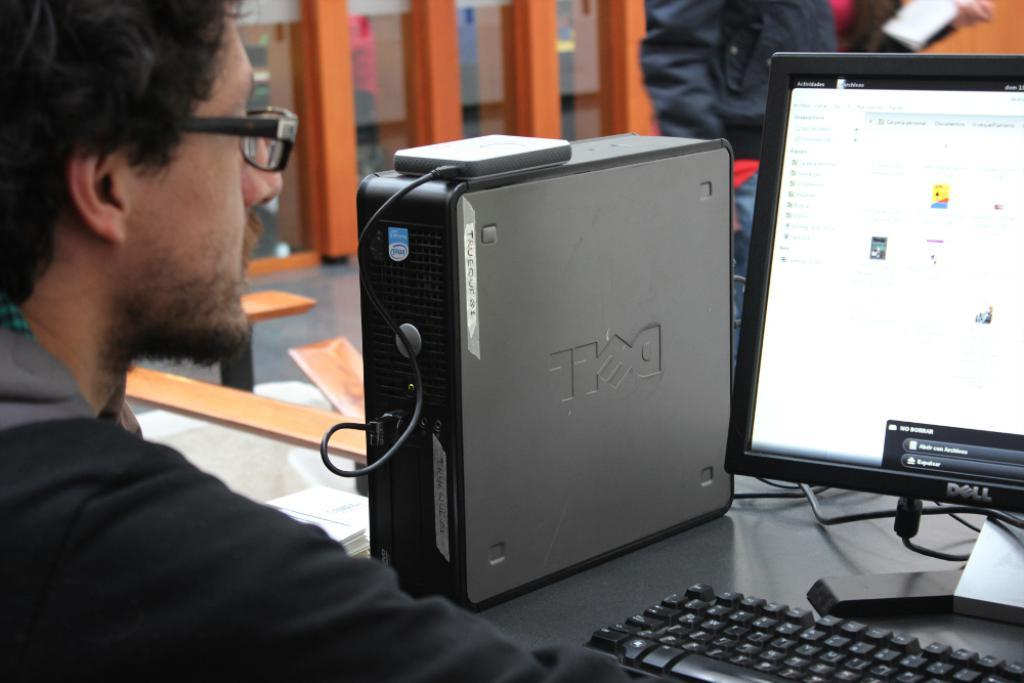<image>
Provide a brief description of the given image. A man with glasses is using a Dell desktop computer. 